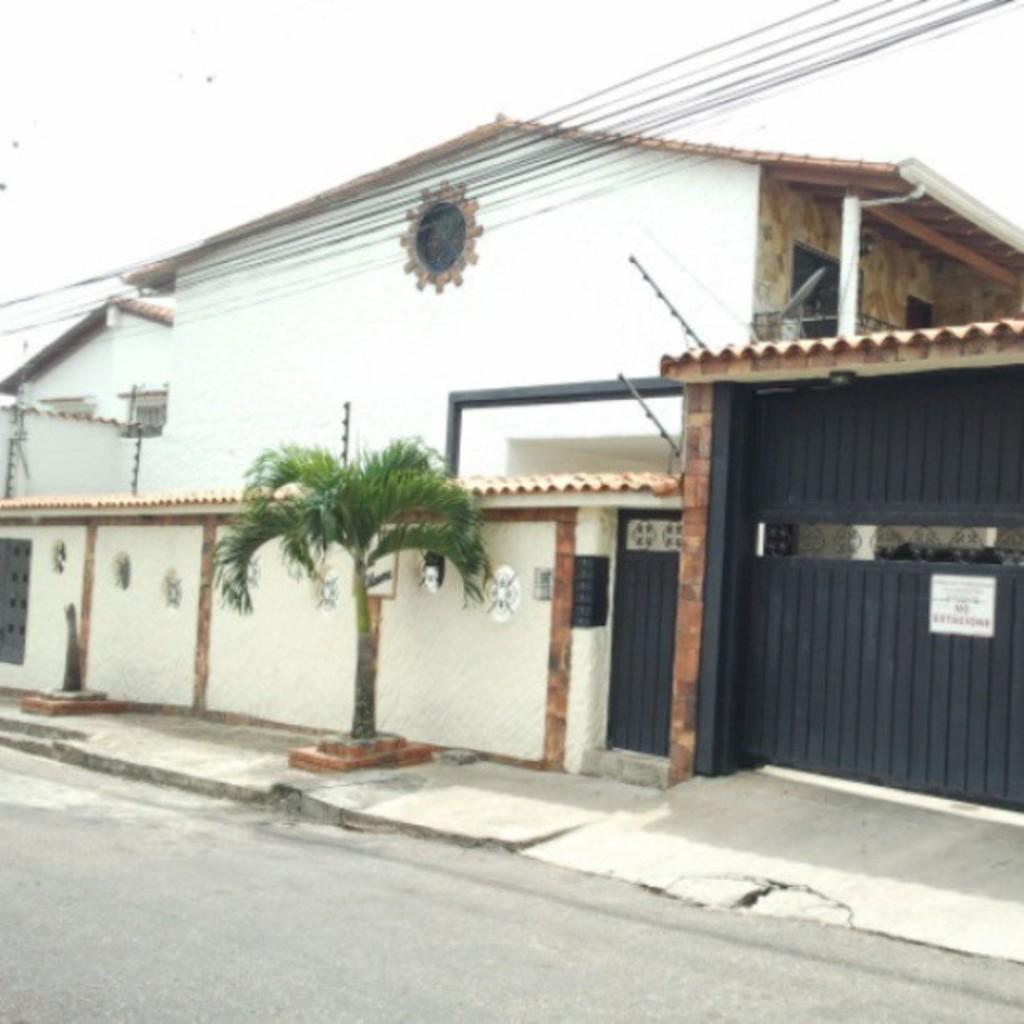Could you give a brief overview of what you see in this image? In this image, we can see houses and there are gates, some posters and there is a tree. At the top, there is sky and at the bottom, there is a road. 